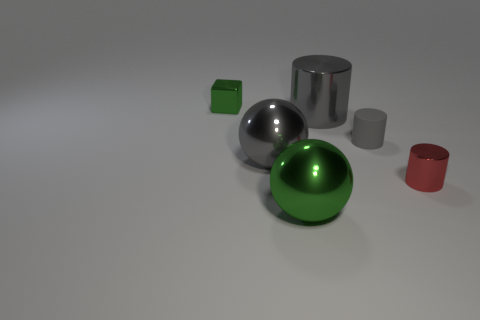How many other objects are the same color as the metal cube?
Provide a short and direct response. 1. There is a tiny thing that is to the left of the large green shiny sphere; is it the same color as the big metallic cylinder?
Ensure brevity in your answer.  No. There is a large metal cylinder; is it the same color as the sphere that is in front of the red cylinder?
Offer a terse response. No. Are there any gray matte cylinders to the left of the gray shiny cylinder?
Make the answer very short. No. Does the large cylinder have the same material as the tiny red cylinder?
Ensure brevity in your answer.  Yes. There is a gray object that is the same size as the green metallic block; what is it made of?
Offer a terse response. Rubber. How many objects are either metallic objects right of the tiny metallic cube or small metallic things?
Give a very brief answer. 5. Are there an equal number of gray rubber cylinders that are behind the red cylinder and purple cylinders?
Offer a very short reply. No. Is the small metal cube the same color as the matte cylinder?
Offer a very short reply. No. What color is the metallic object that is to the left of the big green object and behind the small gray matte object?
Provide a short and direct response. Green. 